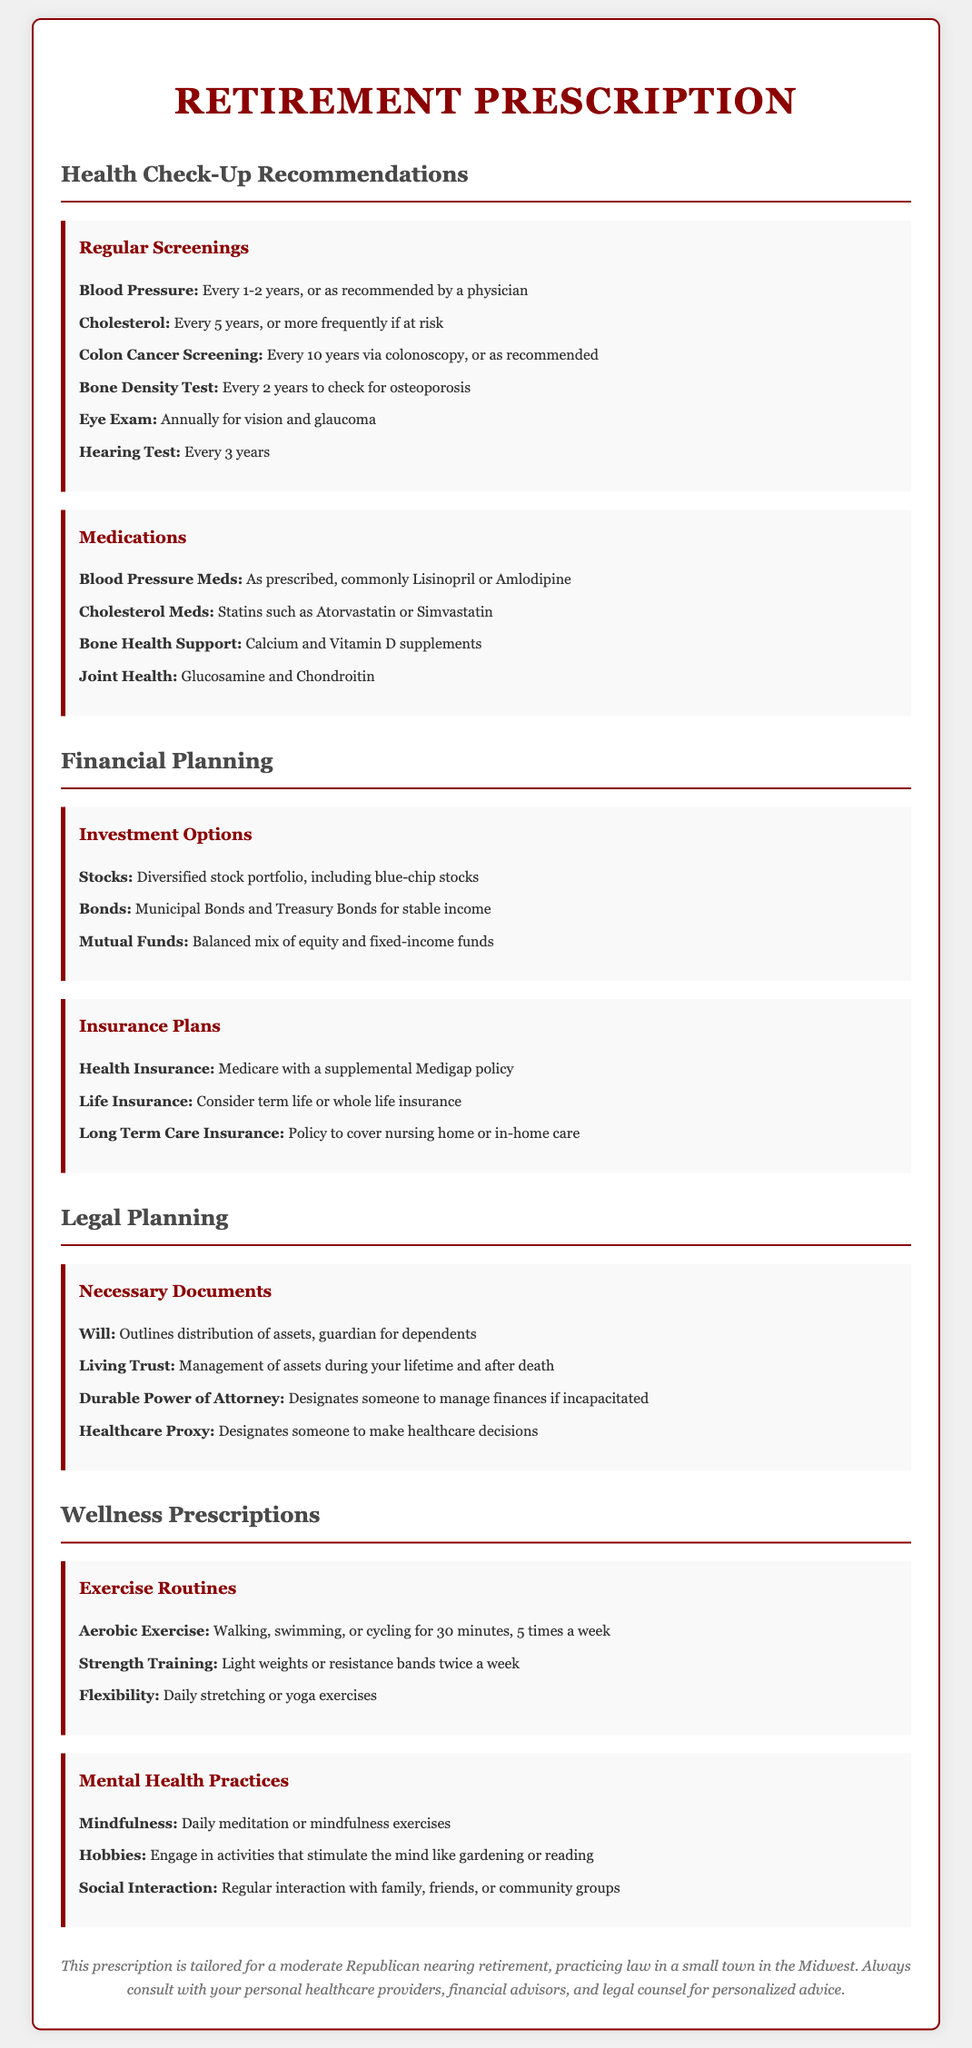What is the recommended frequency for a cholesterol screening? The document states cholesterol screening should be done every 5 years, or more frequently if at risk.
Answer: Every 5 years What are common medications for bone health support? The document lists Calcium and Vitamin D supplements as common medications for bone health support.
Answer: Calcium and Vitamin D supplements What type of exercise is recommended for flexibility? Flexibility is addressed through daily stretching or yoga exercises according to the document.
Answer: Daily stretching or yoga exercises What insurance plan is mentioned to cover nursing home care? The document mentions that Long Term Care Insurance can cover nursing home or in-home care.
Answer: Long Term Care Insurance How often should a hearing test be conducted? The document states that a hearing test should be conducted every 3 years.
Answer: Every 3 years What is required to designate someone to manage finances if incapacitated? A Durable Power of Attorney is needed to designate someone to manage finances if incapacitated according to the document.
Answer: Durable Power of Attorney What kind of portfolio is suggested for investment options? The document suggests a diversified stock portfolio, including blue-chip stocks as a type of investment option.
Answer: Diversified stock portfolio How many times per week should aerobic exercise be performed? The document states that aerobic exercise should be performed for 30 minutes, 5 times a week.
Answer: 5 times a week 